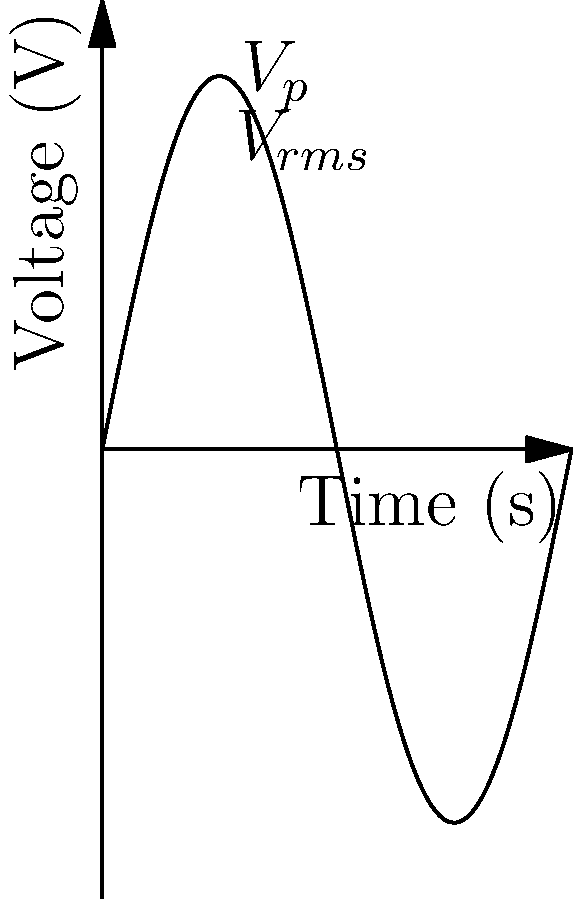In the voltage-time graph of an alternating current circuit shown above, if the peak voltage ($V_p$) is 5 V, what is the root mean square (RMS) voltage ($V_{rms}$)? Relate your answer to a scene from Deepika Padukone's performance in "Chennai Express" where her character experiences ups and downs, much like the sinusoidal wave depicted. To solve this problem, let's break it down step-by-step:

1. Recall the relationship between peak voltage ($V_p$) and RMS voltage ($V_{rms}$) for a sinusoidal AC waveform:

   $V_{rms} = \frac{V_p}{\sqrt{2}}$

2. We're given that the peak voltage $V_p = 5$ V.

3. Substituting this value into the formula:

   $V_{rms} = \frac{5}{\sqrt{2}}$

4. Simplify:
   
   $V_{rms} = 5 \cdot \frac{1}{\sqrt{2}} \approx 3.54$ V

5. Drawing a parallel to Deepika Padukone's performance in "Chennai Express", we can think of the peak voltage as the highest emotional points in her character's journey, while the RMS voltage represents the overall impact of her performance throughout the film. Just as the RMS voltage is a measure of the average power of the AC signal, Deepika's consistent acting prowess throughout the movie contributes to its overall impact, even if it's not always at the peak intensity.
Answer: $3.54$ V 